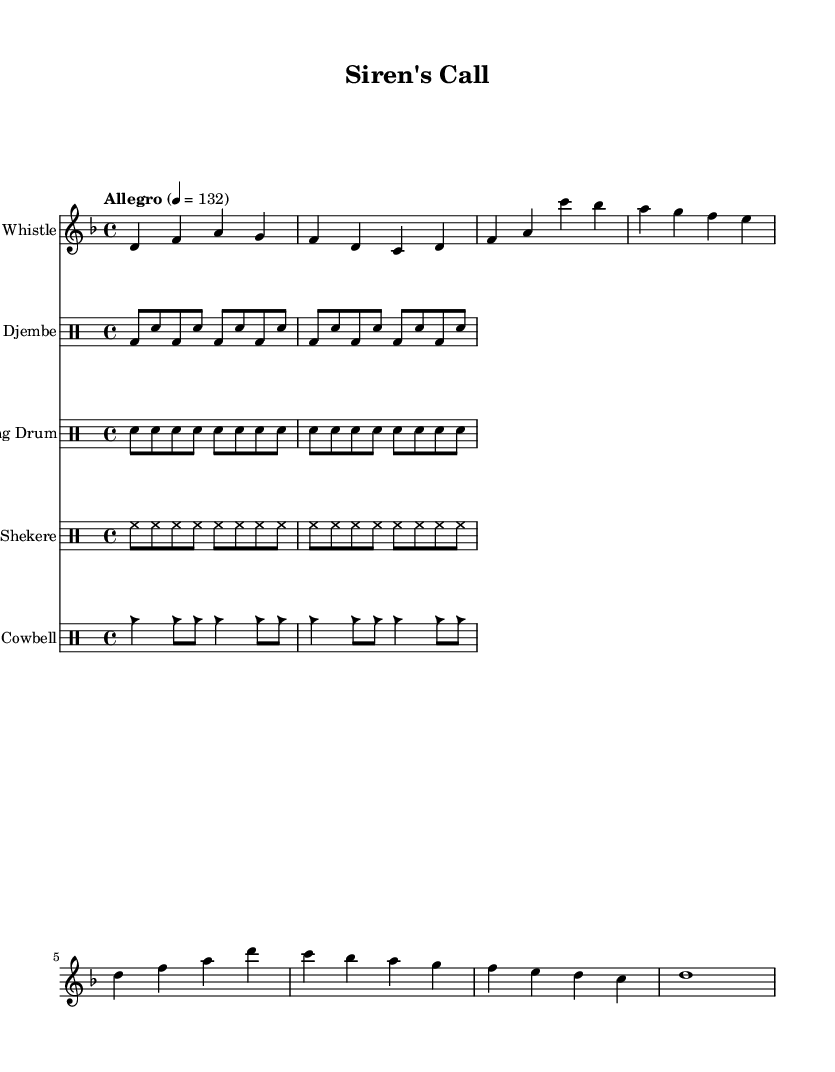What is the key signature of this music? The key signature is D minor, indicated by one flat (B flat). You can identify the key signature by looking at the beginning of the staff where the flat is placed before the notes.
Answer: D minor What is the time signature of this music? The time signature is 4/4, which is commonly found in popular and traditional musics. This can be identified at the beginning of the sheet music where the numbers '4/4' are displayed.
Answer: 4/4 What is the tempo marking of this piece? The tempo marking is Allegro, which indicates a fast pace for the music. The tempo also has a BPM value (132), which is shown in the notation.
Answer: Allegro How many different percussion instruments are used in the score? The score features five different percussion instruments: Djembe, Talking Drum, Shekere, Cowbell, and Whistle. This can be determined by counting the number of distinct lines and instrument names labeled in the music notation.
Answer: Five What is the main rhythmic pattern of the djembe? The djembe plays a repeated pattern of bass (bd) and snare (sn) hits, which play an 8th note rhythm followed by a snare hit. This is evident from the notation in the djembe line, where the symbols for bass and snare are used in a structured pattern.
Answer: Bass and snare Why is the shekere notated with a closed hi-hat? The shekere is notated using hi-hat symbols, indicating a continuous pattern typical of many global music styles. The notation suggests a consistent emphasis on the offbeats, creating a driving rhythmic pulse often found in African music.
Answer: Hi-hat What type of call-and-response can be heard between the whistle and the drums? The whistle part leads with melodic phrases, while the drumming layers provide responsive punctuations, effectively creating a call-and-response dynamic. This is characteristic of interactive African musical traditions.
Answer: Call-and-response 